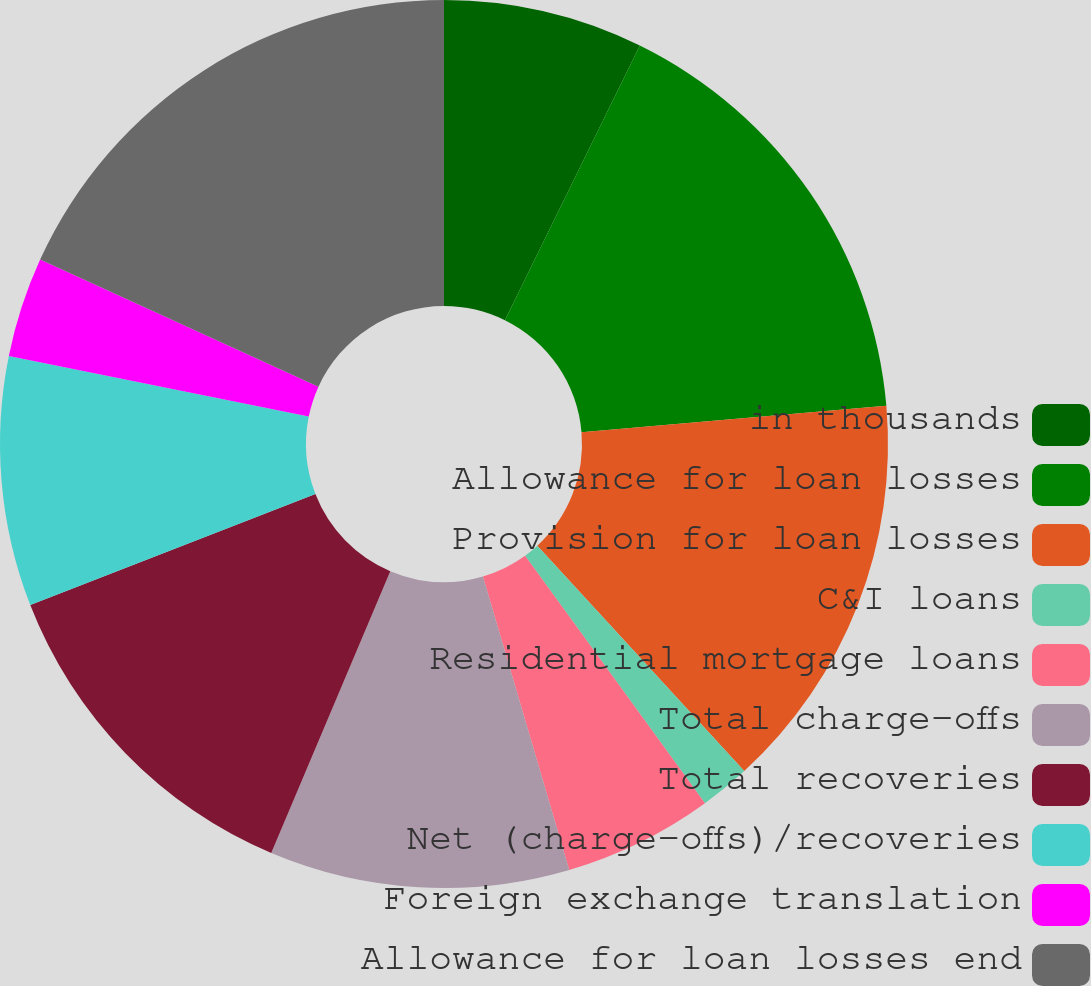Convert chart. <chart><loc_0><loc_0><loc_500><loc_500><pie_chart><fcel>in thousands<fcel>Allowance for loan losses<fcel>Provision for loan losses<fcel>C&I loans<fcel>Residential mortgage loans<fcel>Total charge-offs<fcel>Total recoveries<fcel>Net (charge-offs)/recoveries<fcel>Foreign exchange translation<fcel>Allowance for loan losses end<nl><fcel>7.27%<fcel>16.36%<fcel>14.55%<fcel>1.82%<fcel>5.45%<fcel>10.91%<fcel>12.73%<fcel>9.09%<fcel>3.64%<fcel>18.18%<nl></chart> 